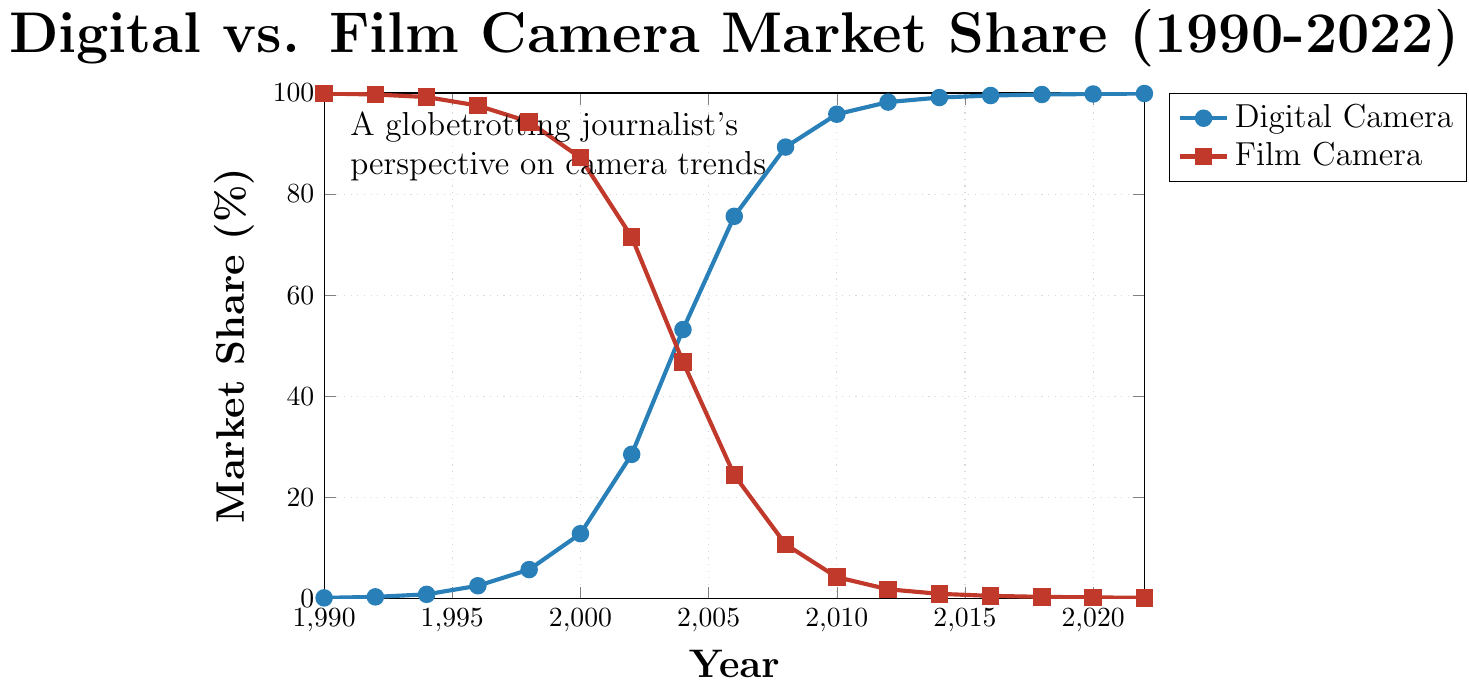What year did digital cameras surpass film cameras in market share? By looking at where the digital camera line intersects and exceeds the film camera line, we find that this happens in 2004.
Answer: 2004 Between which years did the digital camera market share experience the sharpest increase? The sharpest increase can be observed by looking at the line with the steepest slope. From 2002 to 2004, digital camera market share increased from 28.5% to 53.2%.
Answer: 2002 to 2004 What was the market share of film cameras in 1996? By looking at the data point for film cameras in 1996, the market share was 97.5%.
Answer: 97.5% By how many percentage points did digital camera market share increase between 2000 and 2010? Subtract the digital camera market share in 2000 from its share in 2010. 95.8% - 12.8% = 83 percentage points.
Answer: 83 Which camera type had a higher market share in 2008 and by how much? In 2008, digital cameras had a market share of 89.3%, while film cameras had 10.7%. The difference is 89.3% - 10.7% = 78.6%.
Answer: Digital cameras by 78.6% What was the market share of digital cameras in 2012? The data point for digital cameras in 2012 shows a market share of 98.2%.
Answer: 98.2% By what percentage did the film camera market share decrease between 1990 and 2000? Subtract the film camera market share in 2000 from its share in 1990. 99.9% - 87.2% = 12.7%.
Answer: 12.7% What were the market share values for both camera types in 2022? In 2022, the market share for digital cameras was 99.9% and for film cameras, it was 0.1%.
Answer: Digital: 99.9%, Film: 0.1% Which year marks the first time the digital camera market share exceeded 50%? The digital camera market share first surpassed 50% in 2004.
Answer: 2004 